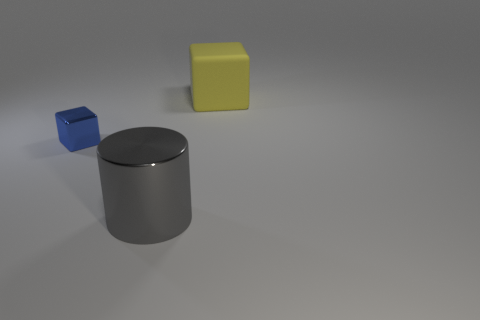Is there any other thing that has the same size as the metallic block?
Your response must be concise. No. There is a thing that is made of the same material as the big cylinder; what size is it?
Offer a very short reply. Small. What is the shape of the big object on the left side of the cube on the right side of the tiny blue metal thing?
Ensure brevity in your answer.  Cylinder. What number of gray objects are big metallic cylinders or metallic things?
Your answer should be very brief. 1. There is a thing to the left of the shiny object that is in front of the blue metallic block; is there a blue block to the left of it?
Keep it short and to the point. No. Is there any other thing that is the same material as the large yellow cube?
Your answer should be compact. No. What number of large things are either cyan balls or gray cylinders?
Your answer should be very brief. 1. There is a big object that is in front of the tiny object; is its shape the same as the rubber thing?
Keep it short and to the point. No. Is the number of big blue shiny spheres less than the number of large gray cylinders?
Keep it short and to the point. Yes. What shape is the large thing behind the metallic cube?
Your answer should be compact. Cube. 